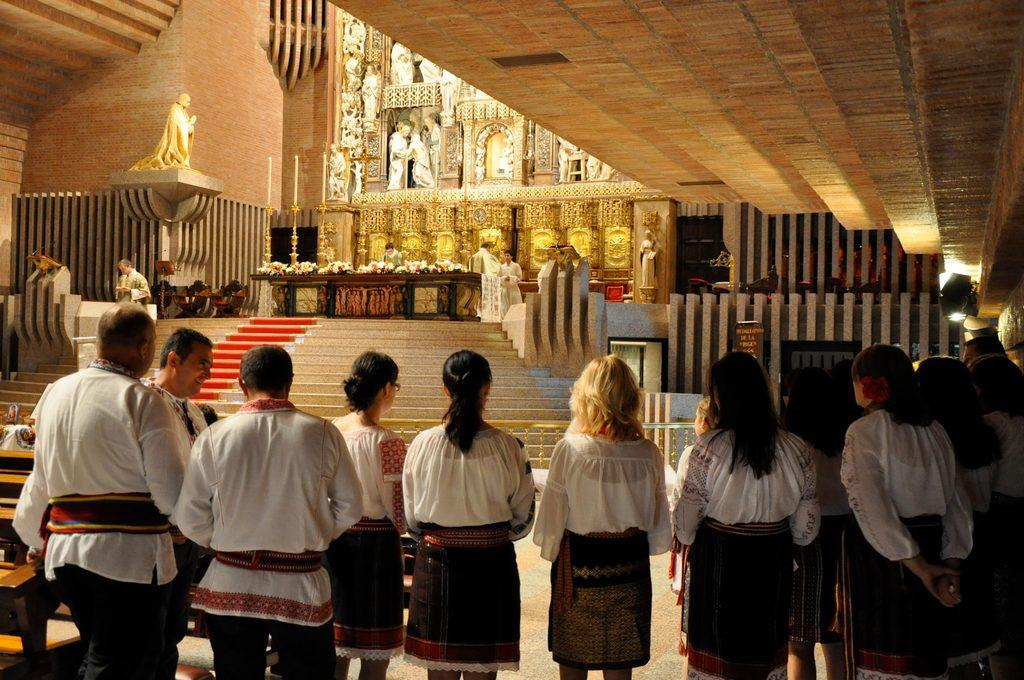Who or what can be seen in the image? There are people in the image. What architectural feature is present in the image? There are stairs in the image. What decorative elements are in the image? There are statues in the image. What type of furniture is visible in the image? There are tables in the image. What structural element can be seen in the background of the image? There is a wall in the image. What color is the ink on the kitten's suit in the image? There is no kitten or suit present in the image. 